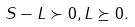<formula> <loc_0><loc_0><loc_500><loc_500>S - L \succ 0 , L \succeq 0 .</formula> 